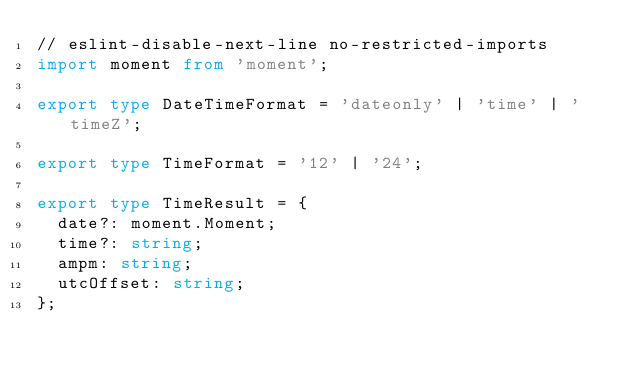<code> <loc_0><loc_0><loc_500><loc_500><_TypeScript_>// eslint-disable-next-line no-restricted-imports
import moment from 'moment';

export type DateTimeFormat = 'dateonly' | 'time' | 'timeZ';

export type TimeFormat = '12' | '24';

export type TimeResult = {
  date?: moment.Moment;
  time?: string;
  ampm: string;
  utcOffset: string;
};
</code> 